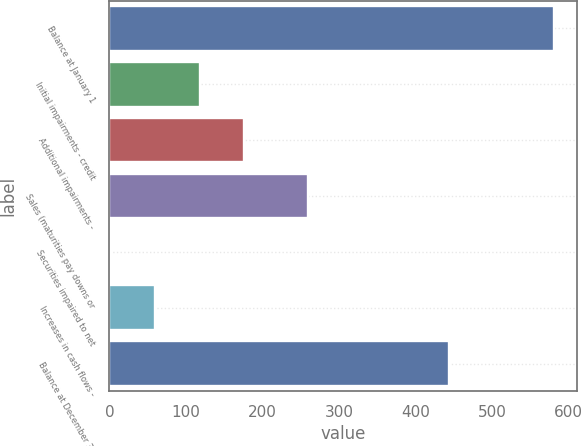Convert chart. <chart><loc_0><loc_0><loc_500><loc_500><bar_chart><fcel>Balance at January 1<fcel>Initial impairments - credit<fcel>Additional impairments -<fcel>Sales (maturities pay downs or<fcel>Securities impaired to net<fcel>Increases in cash flows -<fcel>Balance at December 31<nl><fcel>581<fcel>117.8<fcel>175.7<fcel>260<fcel>2<fcel>59.9<fcel>443<nl></chart> 